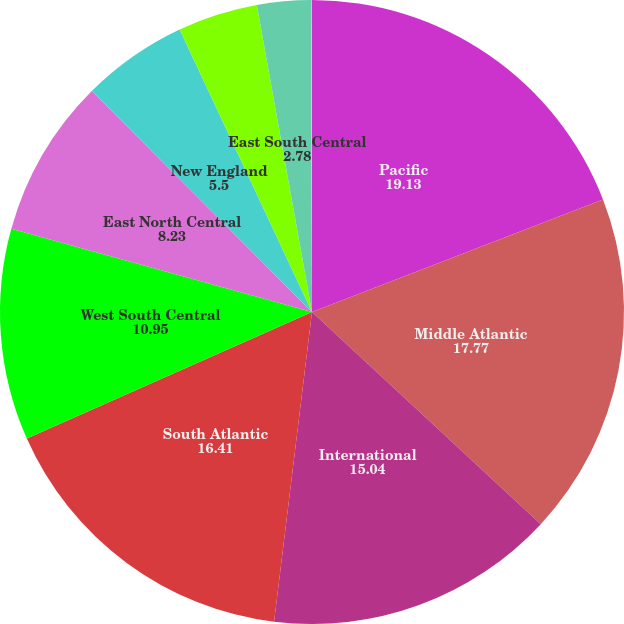<chart> <loc_0><loc_0><loc_500><loc_500><pie_chart><fcel>Pacific<fcel>Middle Atlantic<fcel>International<fcel>South Atlantic<fcel>West South Central<fcel>East North Central<fcel>New England<fcel>Mountain<fcel>East South Central<fcel>West North Central<nl><fcel>19.13%<fcel>17.77%<fcel>15.04%<fcel>16.41%<fcel>10.95%<fcel>8.23%<fcel>5.5%<fcel>4.14%<fcel>2.78%<fcel>0.05%<nl></chart> 